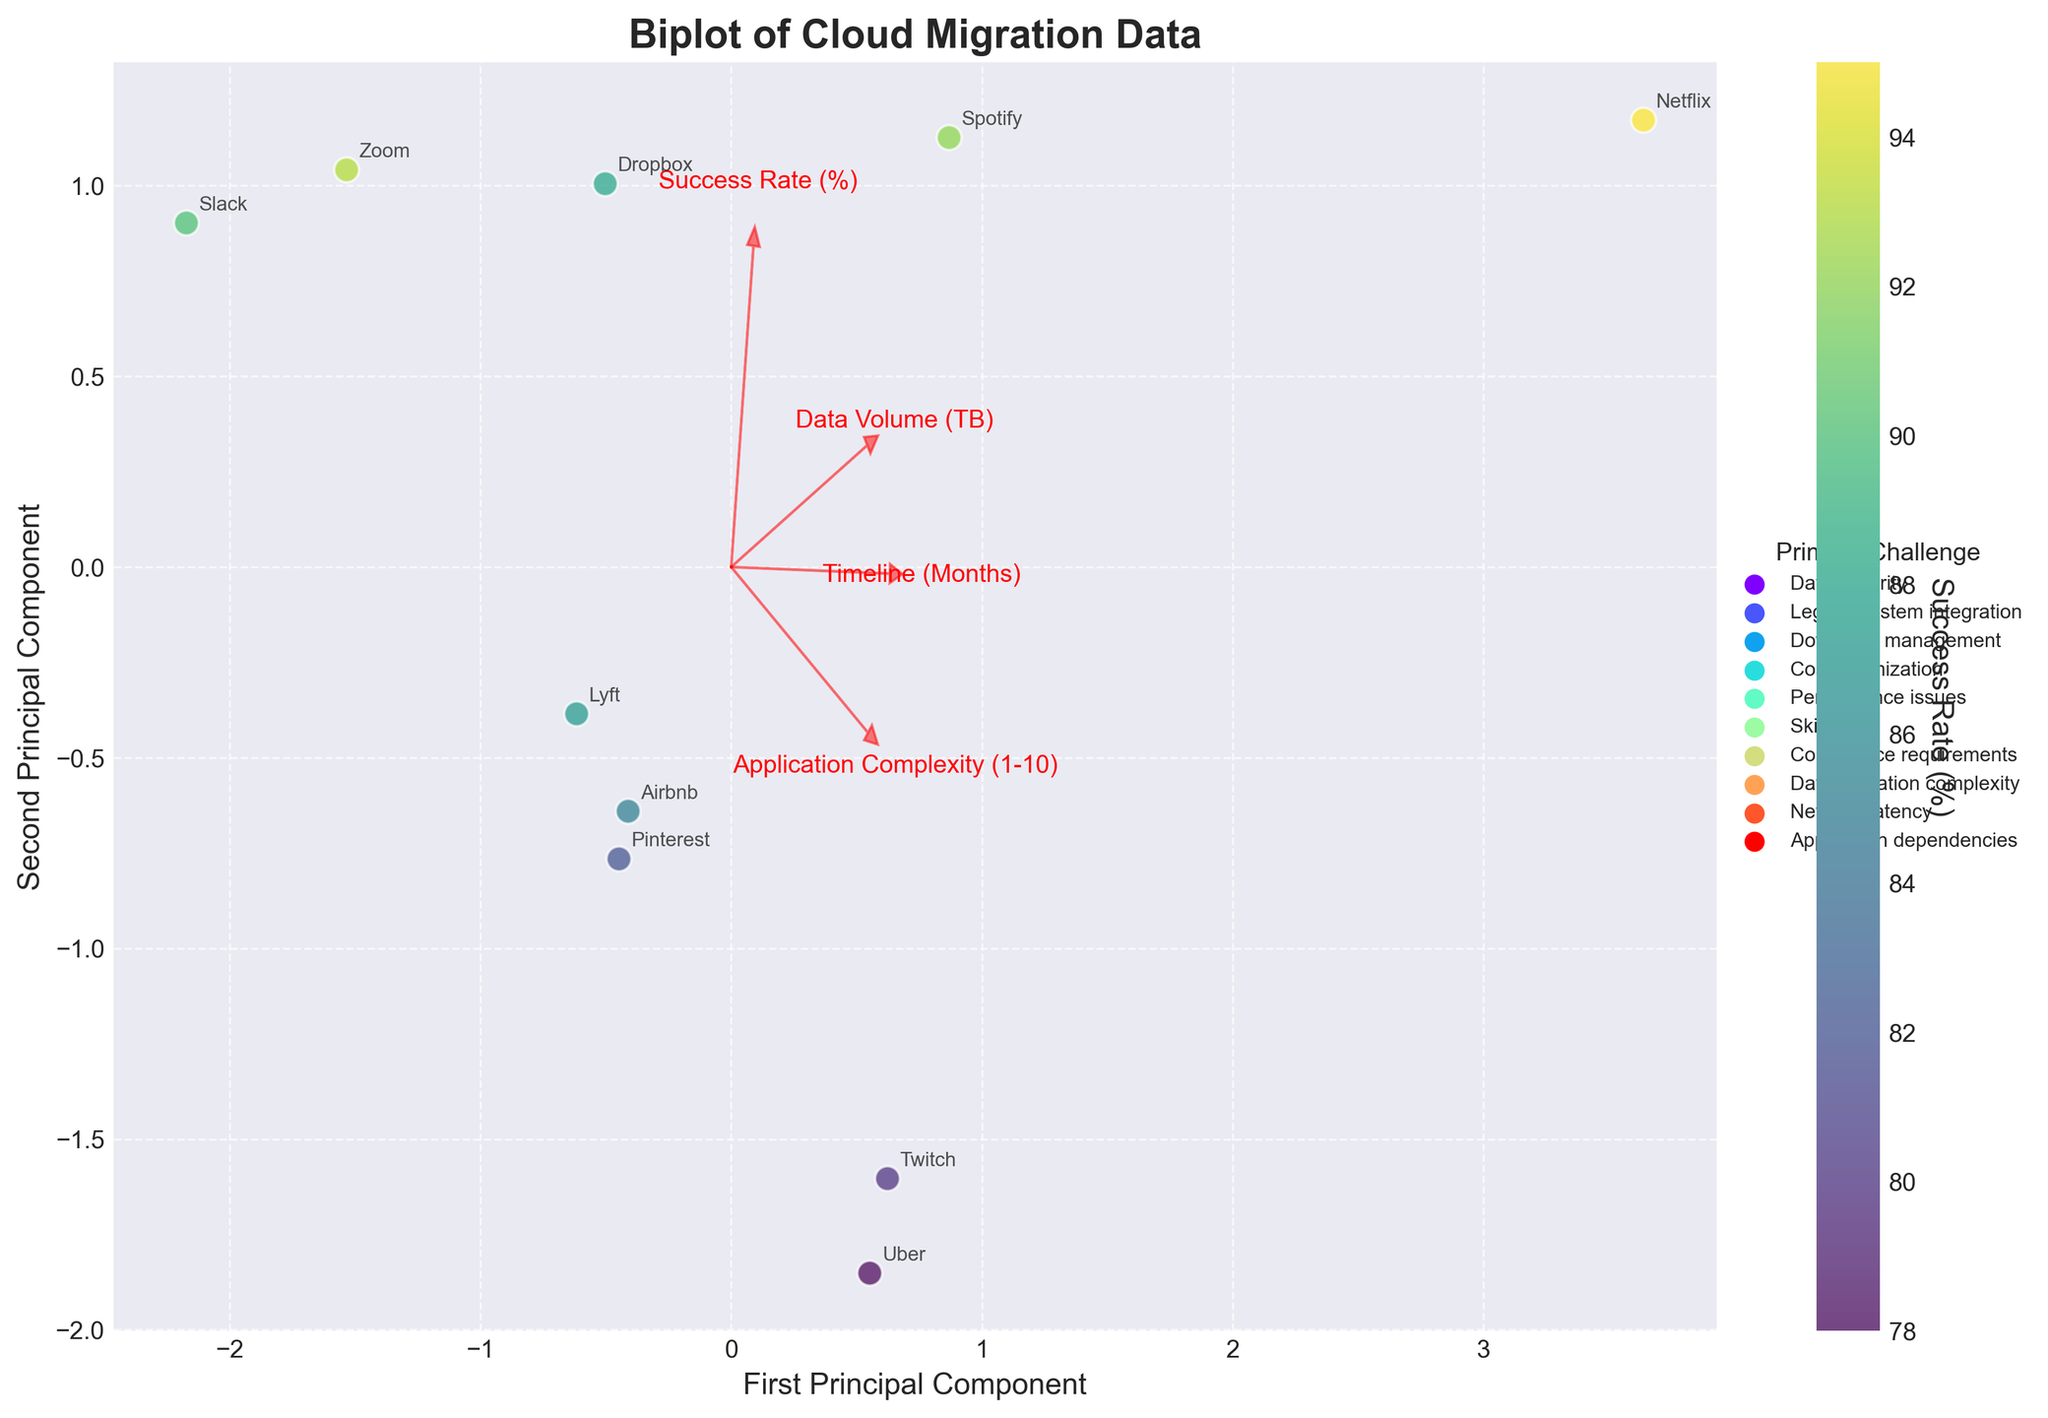How many organizations are represented in the plot? Count the number of data points labeled with organization names in the plot. There are 10 labeled data points, each representing an organization.
Answer: 10 Which organization has the highest success rate? Look at the color of the data points that represent success rates and identify the point with the darkest color (highest success rate). The organization with the highest success rate is Netflix with a success rate of 95%.
Answer: Netflix What is the primary challenge faced by Uber during cloud migration? Locate the data point labeled 'Uber', then check the legend for the corresponding color to find the primary challenge. Uber's primary challenge is Downtime management.
Answer: Downtime management Compare Airbnb and Slack: Which one has a shorter timeline for cloud migration? Locate the data points for Airbnb and Slack, compare their positions along the 'Timeline (Months)' vector shown by the red arrow. Airbnb has a timeline of 12 months and Slack has a timeline of 8 months, so Slack has a shorter timeline.
Answer: Slack Which primary challenge appears most frequently among the organizations? Identify the colors corresponding to each primary challenge in the legend, then count the occurrences of each color in the data points. The challenge "Data security" appears most frequently as it is the challenge for Airbnb and Lyft.
Answer: Data security What is indicated by the length of the vectors in the biplot? The length of the vectors represents the contribution of each feature to the principal components. Longer vectors indicate features with higher contributions. For example, 'Data Volume (TB)' and 'Success Rate (%)' have longer vectors, indicating they contribute significantly to the variability captured by the first two principal components.
Answer: Contribution of features How is 'Application Complexity' related to the first principal component? Look at the direction and length of the 'Application Complexity (1-10)' vector in relation to the first principal component (x-axis). The vector points positively along the first principal component, indicating that higher application complexity contributes positively to the first principal component.
Answer: Positively related Comparing Lyft and Pinterest, which has a higher cloud migration success rate? Locate the data points for Lyft and Pinterest, compare the colors that represent their success rates based on the color bar. Lyft's success rate is 87%, while Pinterest's success rate is 82%. Therefore, Lyft has a higher success rate.
Answer: Lyft Which organization faced 'Network latency' as their primary challenge and what is their success rate? Identify the organization associated with the label 'Network latency' by referring to the legend, then find this organization's data point to check the success rate. Zoom faced 'Network latency' and has a success rate of 93%.
Answer: Zoom, 93% Are organizations with higher data volumes generally facing higher or lower success rates? Observe the data points associated with higher data volumes (based on their position along the 'Data Volume (TB)' vector) and compare their colors (representing success rates). Netflix (2000 TB, 95%), Dropbox (1500 TB, 88%), and Spotify (1200 TB, 92%) have high success rates, indicating that organizations with higher data volumes generally have higher success rates.
Answer: Higher 